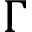Convert formula to latex. <formula><loc_0><loc_0><loc_500><loc_500>\Gamma</formula> 